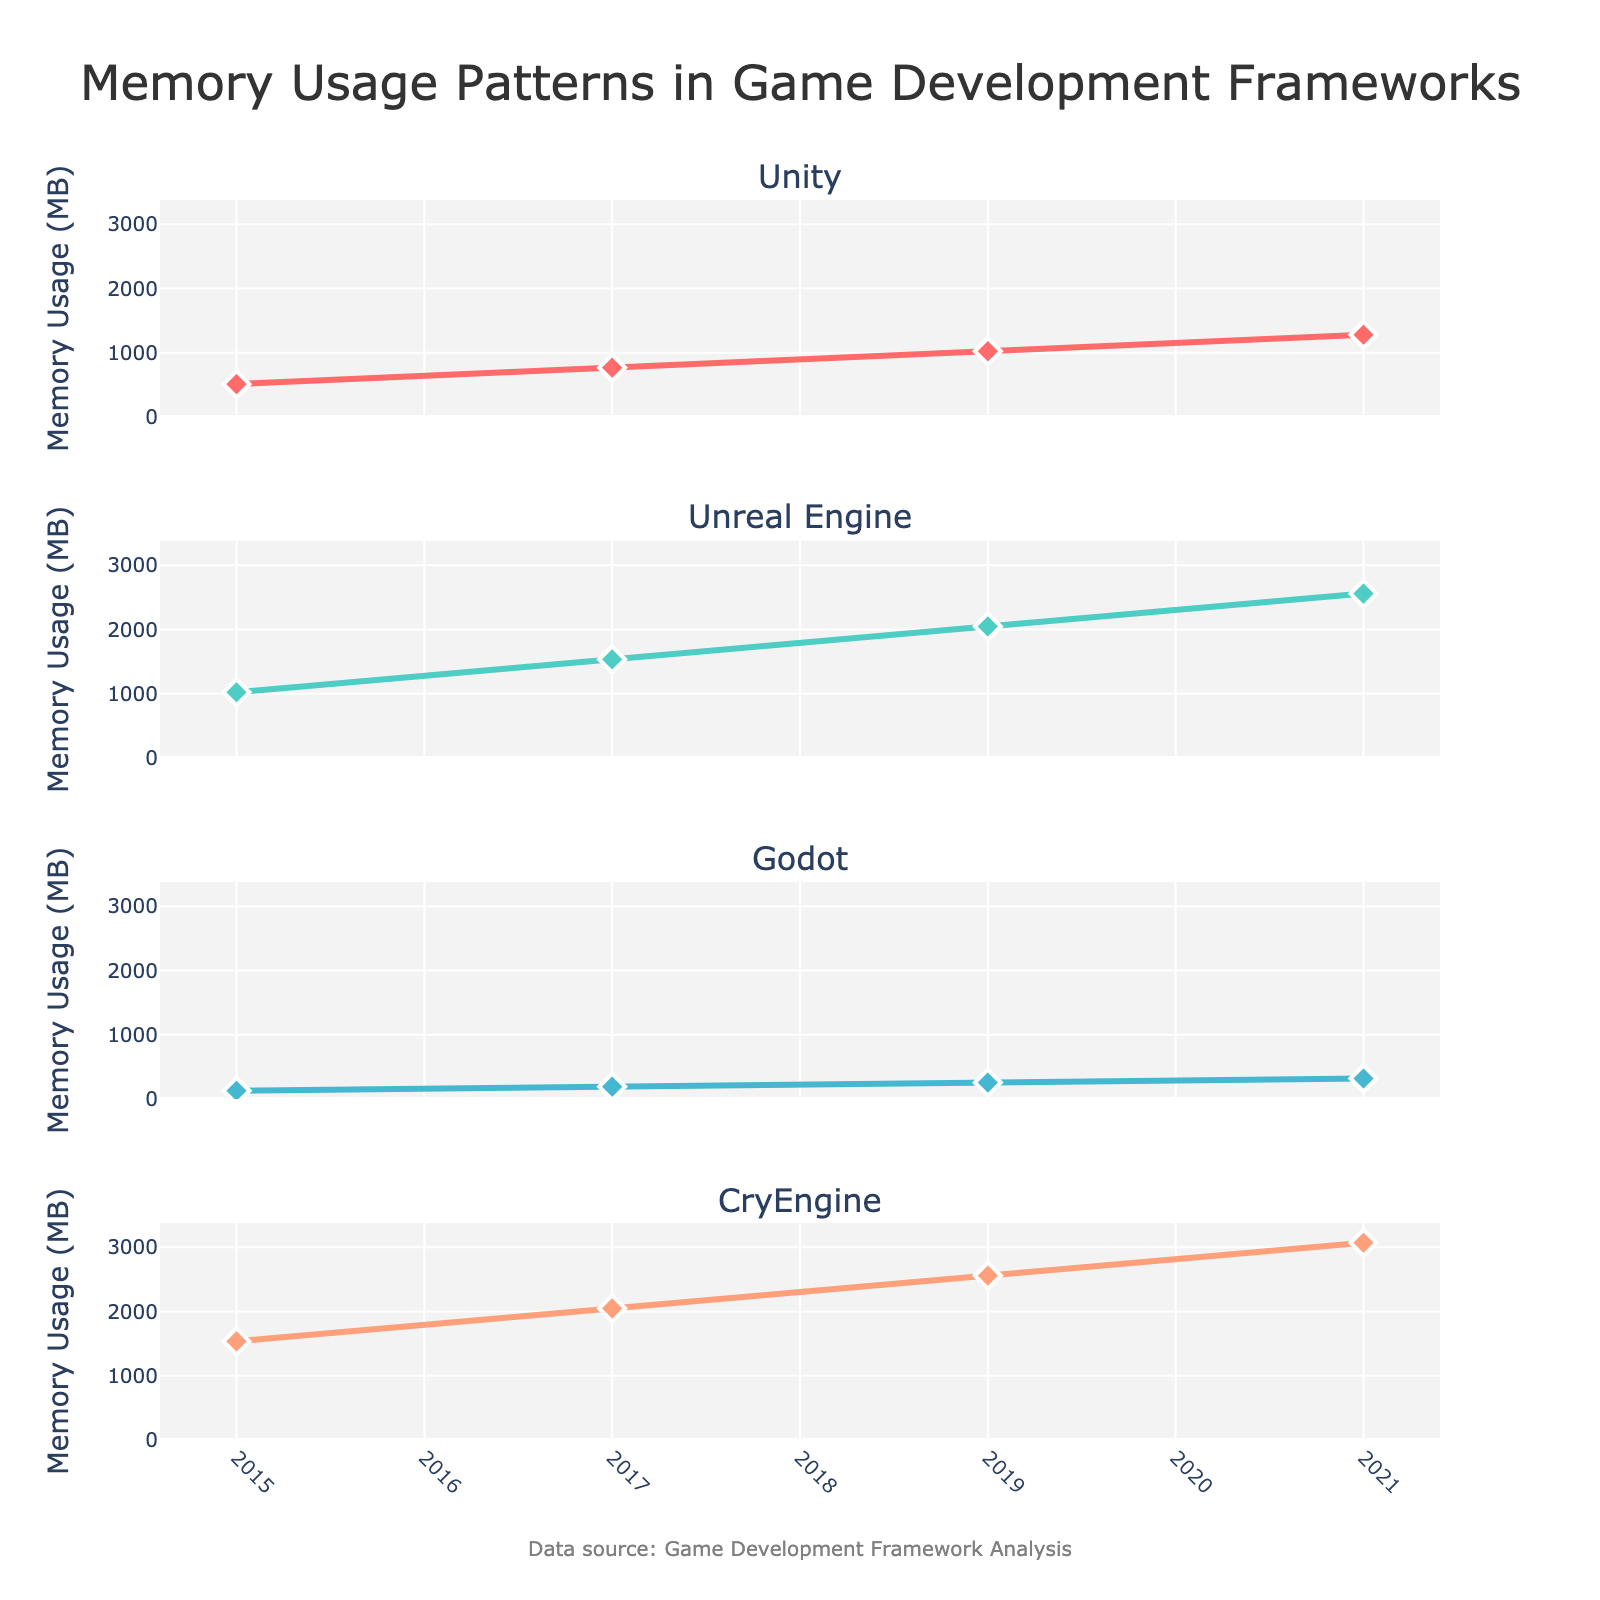What's the primary focus of the figure? The title of the figure is "Memory Usage Patterns in Game Development Frameworks," which indicates that the figure is focusing on the changes in memory usage of different game development frameworks over time.
Answer: Memory usage patterns in game development frameworks Which framework had the highest memory usage in 2015? Looking at the values for 2015 on each subplot, CryEngine had the highest memory usage with 1536 MB.
Answer: CryEngine How did Unity's memory usage change from 2019 to 2021? Comparing the memory usage values for Unity in 2019 (1024 MB) and 2021 (1280 MB), there was an increase of 256 MB.
Answer: Increased by 256 MB Which framework shows the least increase in memory usage over the years depicted? Comparing the memory usage from 2015 to 2021 across all frameworks: Unity increased by 768 MB, Unreal Engine by 1536 MB, Godot by 192 MB, and CryEngine by 1536 MB. Godot shows the least increase.
Answer: Godot What is the general trend in memory usage for all frameworks from 2015 to 2021? All frameworks' memory usage increases from 2015 to 2021, indicating a general upward trend.
Answer: Upward trend In what year did Unreal Engine surpass a memory usage of 2000 MB? Observing the subplot for Unreal Engine, in 2019 the memory usage was 2048 MB, which is the first year it surpassed 2000 MB.
Answer: 2019 Calculate the average memory usage for CryEngine over the years shown. The values for CryEngine are 1536, 2048, 2560, and 3072 MB. The sum of these values is 9216 MB. Dividing by 4 (number of years), the average is 9216/4 = 2304 MB.
Answer: 2304 MB What was the memory usage for Godot in 2017? Referring to the subplot for Godot, the memory usage in 2017 was 192 MB.
Answer: 192 MB How does the memory usage growth of Unity compare to that of Unreal Engine from 2015 to 2021? Unity's memory usage increased from 512 MB to 1280 MB, an increase of 768 MB. Unreal Engine's memory usage increased from 1024 MB to 2560 MB, an increase of 1536 MB. Unreal Engine's increase is twice that of Unity's.
Answer: Unreal Engine's growth is twice that of Unity's What can be deduced about the memory usage trajectory of CryEngine compared to the other frameworks? CryEngine consistently has the highest memory usage in all years depicted. Its trajectory shows the most significant absolute increase compared to other frameworks, indicating higher resource requirements or more complex features.
Answer: Most significant increase in memory usage 